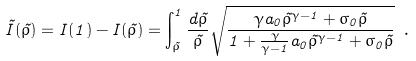<formula> <loc_0><loc_0><loc_500><loc_500>\tilde { I } ( \tilde { \rho } ) = I ( 1 ) - I ( \tilde { \rho } ) = \int _ { \tilde { \rho } } ^ { 1 } \frac { d \tilde { \rho } } { \tilde { \rho } } \sqrt { \frac { \gamma a _ { 0 } \tilde { \rho } ^ { \gamma - 1 } + \sigma _ { 0 } \tilde { \rho } } { 1 + \frac { \gamma } { \gamma - 1 } a _ { 0 } \tilde { \rho } ^ { \gamma - 1 } + \sigma _ { 0 } \tilde { \rho } } } \ .</formula> 